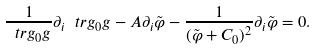<formula> <loc_0><loc_0><loc_500><loc_500>\frac { 1 } { \ t r { g _ { 0 } } { g } } \partial _ { i } \ t r { g _ { 0 } } { g } - A \partial _ { i } \tilde { \varphi } - \frac { 1 } { ( \tilde { \varphi } + C _ { 0 } ) ^ { 2 } } \partial _ { i } \tilde { \varphi } = 0 .</formula> 